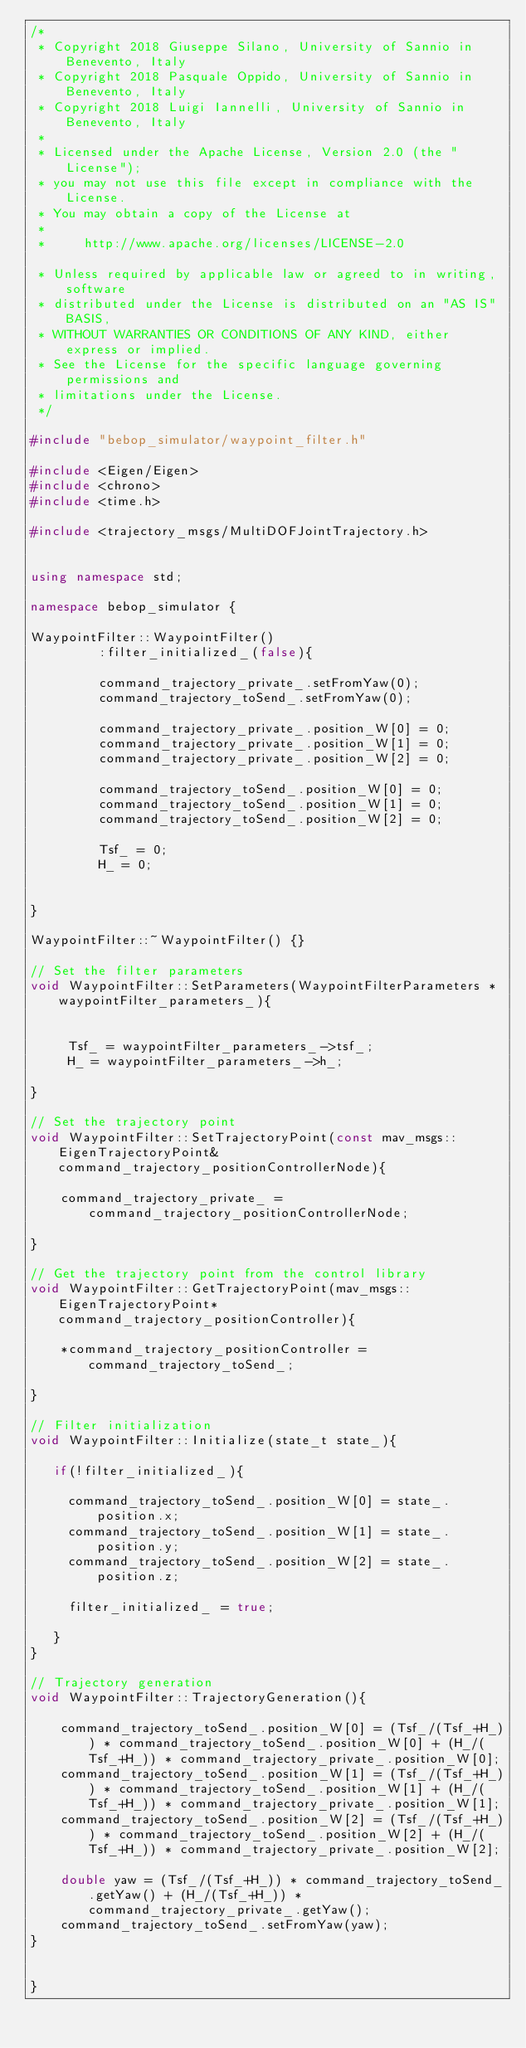<code> <loc_0><loc_0><loc_500><loc_500><_C++_>/*
 * Copyright 2018 Giuseppe Silano, University of Sannio in Benevento, Italy
 * Copyright 2018 Pasquale Oppido, University of Sannio in Benevento, Italy
 * Copyright 2018 Luigi Iannelli, University of Sannio in Benevento, Italy
 *
 * Licensed under the Apache License, Version 2.0 (the "License");
 * you may not use this file except in compliance with the License.
 * You may obtain a copy of the License at
 *
 *     http://www.apache.org/licenses/LICENSE-2.0

 * Unless required by applicable law or agreed to in writing, software
 * distributed under the License is distributed on an "AS IS" BASIS,
 * WITHOUT WARRANTIES OR CONDITIONS OF ANY KIND, either express or implied.
 * See the License for the specific language governing permissions and
 * limitations under the License.
 */

#include "bebop_simulator/waypoint_filter.h"

#include <Eigen/Eigen>
#include <chrono>
#include <time.h>

#include <trajectory_msgs/MultiDOFJointTrajectory.h>


using namespace std;

namespace bebop_simulator {

WaypointFilter::WaypointFilter()
         :filter_initialized_(false){

         command_trajectory_private_.setFromYaw(0);
         command_trajectory_toSend_.setFromYaw(0);

         command_trajectory_private_.position_W[0] = 0;
         command_trajectory_private_.position_W[1] = 0;
         command_trajectory_private_.position_W[2] = 0;

         command_trajectory_toSend_.position_W[0] = 0;
         command_trajectory_toSend_.position_W[1] = 0;
         command_trajectory_toSend_.position_W[2] = 0;

         Tsf_ = 0;
         H_ = 0;


}

WaypointFilter::~WaypointFilter() {}

// Set the filter parameters
void WaypointFilter::SetParameters(WaypointFilterParameters *waypointFilter_parameters_){


     Tsf_ = waypointFilter_parameters_->tsf_;
     H_ = waypointFilter_parameters_->h_;

}

// Set the trajectory point
void WaypointFilter::SetTrajectoryPoint(const mav_msgs::EigenTrajectoryPoint& command_trajectory_positionControllerNode){

    command_trajectory_private_ = command_trajectory_positionControllerNode;

}

// Get the trajectory point from the control library
void WaypointFilter::GetTrajectoryPoint(mav_msgs::EigenTrajectoryPoint* command_trajectory_positionController){

    *command_trajectory_positionController = command_trajectory_toSend_;

}

// Filter initialization
void WaypointFilter::Initialize(state_t state_){

   if(!filter_initialized_){

     command_trajectory_toSend_.position_W[0] = state_.position.x;
     command_trajectory_toSend_.position_W[1] = state_.position.y;
     command_trajectory_toSend_.position_W[2] = state_.position.z;

     filter_initialized_ = true;

   }
}

// Trajectory generation
void WaypointFilter::TrajectoryGeneration(){

    command_trajectory_toSend_.position_W[0] = (Tsf_/(Tsf_+H_)) * command_trajectory_toSend_.position_W[0] + (H_/(Tsf_+H_)) * command_trajectory_private_.position_W[0];
    command_trajectory_toSend_.position_W[1] = (Tsf_/(Tsf_+H_)) * command_trajectory_toSend_.position_W[1] + (H_/(Tsf_+H_)) * command_trajectory_private_.position_W[1];
    command_trajectory_toSend_.position_W[2] = (Tsf_/(Tsf_+H_)) * command_trajectory_toSend_.position_W[2] + (H_/(Tsf_+H_)) * command_trajectory_private_.position_W[2];

    double yaw = (Tsf_/(Tsf_+H_)) * command_trajectory_toSend_.getYaw() + (H_/(Tsf_+H_)) * command_trajectory_private_.getYaw();
    command_trajectory_toSend_.setFromYaw(yaw);
}


}
</code> 